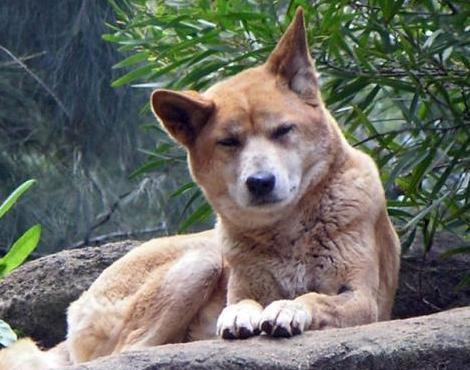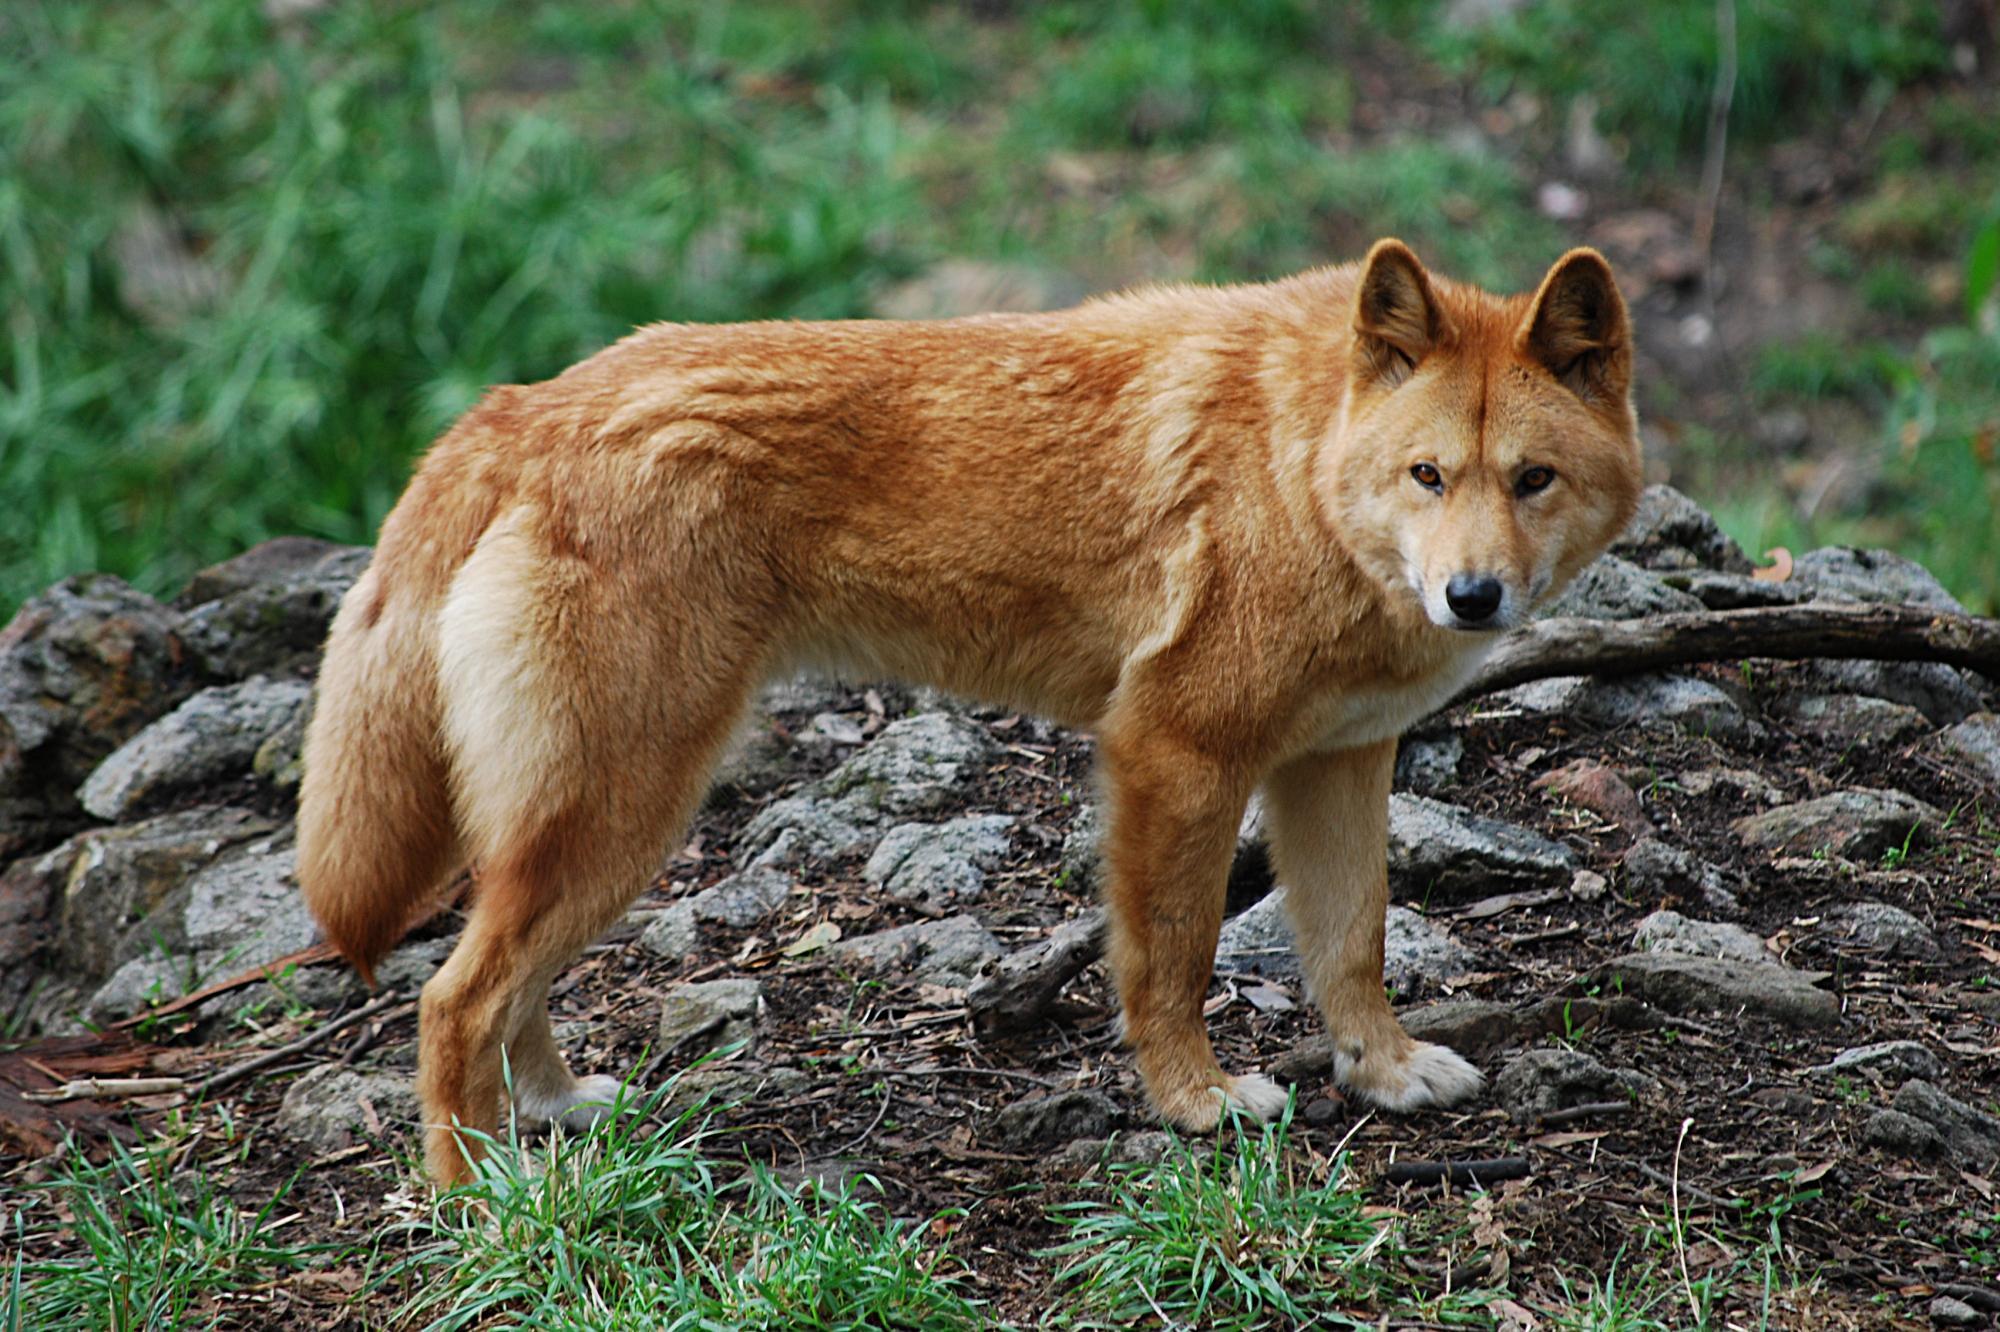The first image is the image on the left, the second image is the image on the right. For the images shown, is this caption "The animal in the image on the right is standing on all fours." true? Answer yes or no. Yes. The first image is the image on the left, the second image is the image on the right. For the images displayed, is the sentence "In the left image, a dog's eyes are narrowed because it looks sleepy." factually correct? Answer yes or no. Yes. 